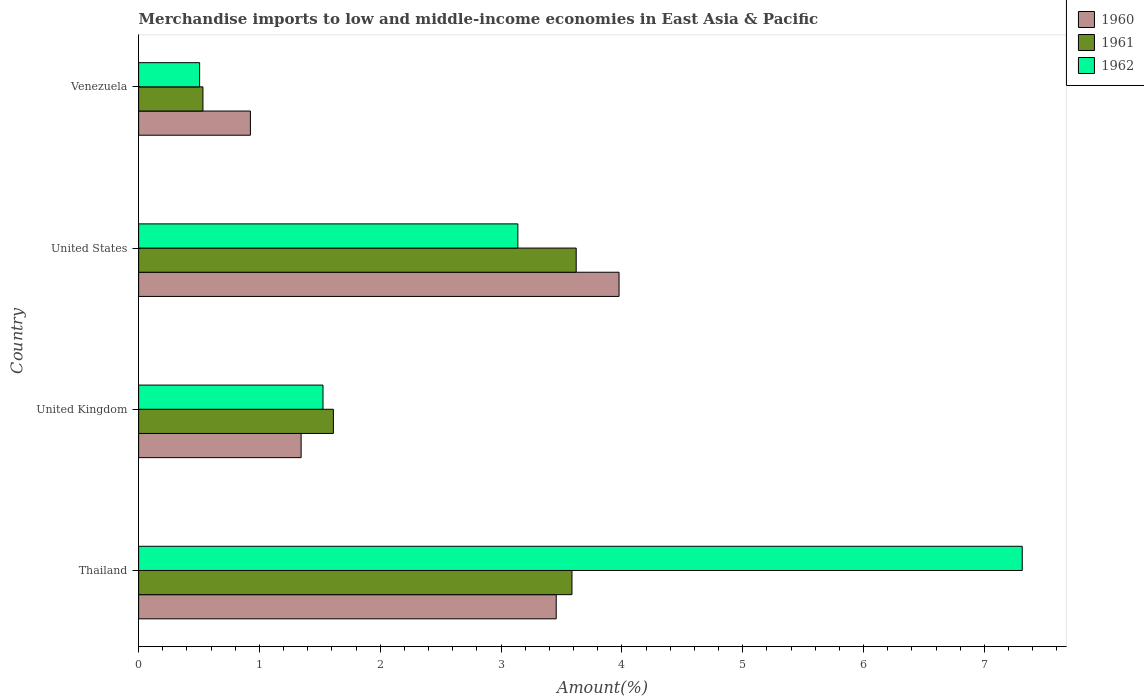How many groups of bars are there?
Your answer should be compact. 4. Are the number of bars per tick equal to the number of legend labels?
Provide a short and direct response. Yes. How many bars are there on the 4th tick from the top?
Make the answer very short. 3. What is the label of the 4th group of bars from the top?
Provide a succinct answer. Thailand. What is the percentage of amount earned from merchandise imports in 1960 in Thailand?
Offer a terse response. 3.46. Across all countries, what is the maximum percentage of amount earned from merchandise imports in 1960?
Provide a short and direct response. 3.98. Across all countries, what is the minimum percentage of amount earned from merchandise imports in 1961?
Provide a short and direct response. 0.53. In which country was the percentage of amount earned from merchandise imports in 1962 maximum?
Provide a succinct answer. Thailand. In which country was the percentage of amount earned from merchandise imports in 1962 minimum?
Give a very brief answer. Venezuela. What is the total percentage of amount earned from merchandise imports in 1960 in the graph?
Give a very brief answer. 9.7. What is the difference between the percentage of amount earned from merchandise imports in 1960 in Thailand and that in Venezuela?
Your response must be concise. 2.53. What is the difference between the percentage of amount earned from merchandise imports in 1961 in Venezuela and the percentage of amount earned from merchandise imports in 1962 in United States?
Provide a succinct answer. -2.61. What is the average percentage of amount earned from merchandise imports in 1962 per country?
Ensure brevity in your answer.  3.12. What is the difference between the percentage of amount earned from merchandise imports in 1961 and percentage of amount earned from merchandise imports in 1960 in Thailand?
Provide a short and direct response. 0.13. In how many countries, is the percentage of amount earned from merchandise imports in 1960 greater than 3.8 %?
Make the answer very short. 1. What is the ratio of the percentage of amount earned from merchandise imports in 1960 in Thailand to that in United States?
Your response must be concise. 0.87. Is the percentage of amount earned from merchandise imports in 1960 in Thailand less than that in Venezuela?
Provide a short and direct response. No. What is the difference between the highest and the second highest percentage of amount earned from merchandise imports in 1960?
Your answer should be very brief. 0.52. What is the difference between the highest and the lowest percentage of amount earned from merchandise imports in 1961?
Ensure brevity in your answer.  3.09. In how many countries, is the percentage of amount earned from merchandise imports in 1961 greater than the average percentage of amount earned from merchandise imports in 1961 taken over all countries?
Your answer should be very brief. 2. Is the sum of the percentage of amount earned from merchandise imports in 1960 in Thailand and United States greater than the maximum percentage of amount earned from merchandise imports in 1962 across all countries?
Offer a very short reply. Yes. Is it the case that in every country, the sum of the percentage of amount earned from merchandise imports in 1962 and percentage of amount earned from merchandise imports in 1960 is greater than the percentage of amount earned from merchandise imports in 1961?
Give a very brief answer. Yes. How many bars are there?
Keep it short and to the point. 12. Are all the bars in the graph horizontal?
Give a very brief answer. Yes. How many countries are there in the graph?
Your answer should be compact. 4. Are the values on the major ticks of X-axis written in scientific E-notation?
Provide a short and direct response. No. Does the graph contain any zero values?
Keep it short and to the point. No. How are the legend labels stacked?
Your answer should be very brief. Vertical. What is the title of the graph?
Your answer should be very brief. Merchandise imports to low and middle-income economies in East Asia & Pacific. What is the label or title of the X-axis?
Keep it short and to the point. Amount(%). What is the label or title of the Y-axis?
Your response must be concise. Country. What is the Amount(%) of 1960 in Thailand?
Provide a short and direct response. 3.46. What is the Amount(%) of 1961 in Thailand?
Provide a short and direct response. 3.59. What is the Amount(%) of 1962 in Thailand?
Your response must be concise. 7.31. What is the Amount(%) of 1960 in United Kingdom?
Offer a terse response. 1.34. What is the Amount(%) in 1961 in United Kingdom?
Your answer should be compact. 1.61. What is the Amount(%) in 1962 in United Kingdom?
Keep it short and to the point. 1.53. What is the Amount(%) in 1960 in United States?
Offer a very short reply. 3.98. What is the Amount(%) in 1961 in United States?
Offer a very short reply. 3.62. What is the Amount(%) of 1962 in United States?
Give a very brief answer. 3.14. What is the Amount(%) in 1960 in Venezuela?
Offer a very short reply. 0.93. What is the Amount(%) of 1961 in Venezuela?
Your response must be concise. 0.53. What is the Amount(%) in 1962 in Venezuela?
Provide a short and direct response. 0.5. Across all countries, what is the maximum Amount(%) of 1960?
Your answer should be compact. 3.98. Across all countries, what is the maximum Amount(%) of 1961?
Provide a succinct answer. 3.62. Across all countries, what is the maximum Amount(%) of 1962?
Your answer should be very brief. 7.31. Across all countries, what is the minimum Amount(%) in 1960?
Provide a succinct answer. 0.93. Across all countries, what is the minimum Amount(%) in 1961?
Provide a short and direct response. 0.53. Across all countries, what is the minimum Amount(%) of 1962?
Keep it short and to the point. 0.5. What is the total Amount(%) of 1960 in the graph?
Provide a short and direct response. 9.7. What is the total Amount(%) in 1961 in the graph?
Ensure brevity in your answer.  9.35. What is the total Amount(%) in 1962 in the graph?
Give a very brief answer. 12.48. What is the difference between the Amount(%) in 1960 in Thailand and that in United Kingdom?
Offer a very short reply. 2.11. What is the difference between the Amount(%) in 1961 in Thailand and that in United Kingdom?
Provide a succinct answer. 1.97. What is the difference between the Amount(%) of 1962 in Thailand and that in United Kingdom?
Keep it short and to the point. 5.79. What is the difference between the Amount(%) in 1960 in Thailand and that in United States?
Give a very brief answer. -0.52. What is the difference between the Amount(%) of 1961 in Thailand and that in United States?
Your answer should be compact. -0.04. What is the difference between the Amount(%) in 1962 in Thailand and that in United States?
Provide a succinct answer. 4.17. What is the difference between the Amount(%) in 1960 in Thailand and that in Venezuela?
Keep it short and to the point. 2.53. What is the difference between the Amount(%) of 1961 in Thailand and that in Venezuela?
Make the answer very short. 3.05. What is the difference between the Amount(%) of 1962 in Thailand and that in Venezuela?
Provide a succinct answer. 6.81. What is the difference between the Amount(%) in 1960 in United Kingdom and that in United States?
Ensure brevity in your answer.  -2.63. What is the difference between the Amount(%) in 1961 in United Kingdom and that in United States?
Give a very brief answer. -2.01. What is the difference between the Amount(%) in 1962 in United Kingdom and that in United States?
Provide a short and direct response. -1.61. What is the difference between the Amount(%) of 1960 in United Kingdom and that in Venezuela?
Your response must be concise. 0.42. What is the difference between the Amount(%) of 1961 in United Kingdom and that in Venezuela?
Your response must be concise. 1.08. What is the difference between the Amount(%) of 1962 in United Kingdom and that in Venezuela?
Offer a terse response. 1.02. What is the difference between the Amount(%) of 1960 in United States and that in Venezuela?
Offer a terse response. 3.05. What is the difference between the Amount(%) of 1961 in United States and that in Venezuela?
Provide a succinct answer. 3.09. What is the difference between the Amount(%) of 1962 in United States and that in Venezuela?
Your response must be concise. 2.63. What is the difference between the Amount(%) of 1960 in Thailand and the Amount(%) of 1961 in United Kingdom?
Your response must be concise. 1.84. What is the difference between the Amount(%) in 1960 in Thailand and the Amount(%) in 1962 in United Kingdom?
Provide a succinct answer. 1.93. What is the difference between the Amount(%) of 1961 in Thailand and the Amount(%) of 1962 in United Kingdom?
Offer a terse response. 2.06. What is the difference between the Amount(%) in 1960 in Thailand and the Amount(%) in 1961 in United States?
Keep it short and to the point. -0.17. What is the difference between the Amount(%) in 1960 in Thailand and the Amount(%) in 1962 in United States?
Your answer should be very brief. 0.32. What is the difference between the Amount(%) in 1961 in Thailand and the Amount(%) in 1962 in United States?
Make the answer very short. 0.45. What is the difference between the Amount(%) in 1960 in Thailand and the Amount(%) in 1961 in Venezuela?
Make the answer very short. 2.92. What is the difference between the Amount(%) of 1960 in Thailand and the Amount(%) of 1962 in Venezuela?
Your response must be concise. 2.95. What is the difference between the Amount(%) of 1961 in Thailand and the Amount(%) of 1962 in Venezuela?
Provide a succinct answer. 3.08. What is the difference between the Amount(%) of 1960 in United Kingdom and the Amount(%) of 1961 in United States?
Provide a succinct answer. -2.28. What is the difference between the Amount(%) in 1960 in United Kingdom and the Amount(%) in 1962 in United States?
Keep it short and to the point. -1.79. What is the difference between the Amount(%) in 1961 in United Kingdom and the Amount(%) in 1962 in United States?
Offer a very short reply. -1.53. What is the difference between the Amount(%) in 1960 in United Kingdom and the Amount(%) in 1961 in Venezuela?
Give a very brief answer. 0.81. What is the difference between the Amount(%) of 1960 in United Kingdom and the Amount(%) of 1962 in Venezuela?
Offer a terse response. 0.84. What is the difference between the Amount(%) of 1961 in United Kingdom and the Amount(%) of 1962 in Venezuela?
Ensure brevity in your answer.  1.11. What is the difference between the Amount(%) in 1960 in United States and the Amount(%) in 1961 in Venezuela?
Offer a terse response. 3.44. What is the difference between the Amount(%) in 1960 in United States and the Amount(%) in 1962 in Venezuela?
Offer a very short reply. 3.47. What is the difference between the Amount(%) of 1961 in United States and the Amount(%) of 1962 in Venezuela?
Your response must be concise. 3.12. What is the average Amount(%) in 1960 per country?
Provide a succinct answer. 2.43. What is the average Amount(%) of 1961 per country?
Provide a short and direct response. 2.34. What is the average Amount(%) in 1962 per country?
Offer a terse response. 3.12. What is the difference between the Amount(%) of 1960 and Amount(%) of 1961 in Thailand?
Offer a very short reply. -0.13. What is the difference between the Amount(%) in 1960 and Amount(%) in 1962 in Thailand?
Offer a terse response. -3.86. What is the difference between the Amount(%) in 1961 and Amount(%) in 1962 in Thailand?
Offer a very short reply. -3.73. What is the difference between the Amount(%) in 1960 and Amount(%) in 1961 in United Kingdom?
Keep it short and to the point. -0.27. What is the difference between the Amount(%) in 1960 and Amount(%) in 1962 in United Kingdom?
Provide a short and direct response. -0.18. What is the difference between the Amount(%) of 1961 and Amount(%) of 1962 in United Kingdom?
Make the answer very short. 0.09. What is the difference between the Amount(%) of 1960 and Amount(%) of 1961 in United States?
Your answer should be compact. 0.35. What is the difference between the Amount(%) of 1960 and Amount(%) of 1962 in United States?
Give a very brief answer. 0.84. What is the difference between the Amount(%) in 1961 and Amount(%) in 1962 in United States?
Offer a terse response. 0.48. What is the difference between the Amount(%) of 1960 and Amount(%) of 1961 in Venezuela?
Make the answer very short. 0.39. What is the difference between the Amount(%) of 1960 and Amount(%) of 1962 in Venezuela?
Offer a very short reply. 0.42. What is the difference between the Amount(%) in 1961 and Amount(%) in 1962 in Venezuela?
Your response must be concise. 0.03. What is the ratio of the Amount(%) in 1960 in Thailand to that in United Kingdom?
Provide a short and direct response. 2.57. What is the ratio of the Amount(%) of 1961 in Thailand to that in United Kingdom?
Keep it short and to the point. 2.23. What is the ratio of the Amount(%) of 1962 in Thailand to that in United Kingdom?
Make the answer very short. 4.79. What is the ratio of the Amount(%) in 1960 in Thailand to that in United States?
Offer a very short reply. 0.87. What is the ratio of the Amount(%) of 1961 in Thailand to that in United States?
Ensure brevity in your answer.  0.99. What is the ratio of the Amount(%) in 1962 in Thailand to that in United States?
Your response must be concise. 2.33. What is the ratio of the Amount(%) in 1960 in Thailand to that in Venezuela?
Make the answer very short. 3.74. What is the ratio of the Amount(%) of 1961 in Thailand to that in Venezuela?
Your response must be concise. 6.74. What is the ratio of the Amount(%) of 1962 in Thailand to that in Venezuela?
Your answer should be compact. 14.49. What is the ratio of the Amount(%) in 1960 in United Kingdom to that in United States?
Provide a short and direct response. 0.34. What is the ratio of the Amount(%) in 1961 in United Kingdom to that in United States?
Give a very brief answer. 0.45. What is the ratio of the Amount(%) of 1962 in United Kingdom to that in United States?
Ensure brevity in your answer.  0.49. What is the ratio of the Amount(%) of 1960 in United Kingdom to that in Venezuela?
Your answer should be compact. 1.45. What is the ratio of the Amount(%) of 1961 in United Kingdom to that in Venezuela?
Keep it short and to the point. 3.03. What is the ratio of the Amount(%) of 1962 in United Kingdom to that in Venezuela?
Keep it short and to the point. 3.02. What is the ratio of the Amount(%) of 1960 in United States to that in Venezuela?
Make the answer very short. 4.3. What is the ratio of the Amount(%) of 1961 in United States to that in Venezuela?
Ensure brevity in your answer.  6.8. What is the ratio of the Amount(%) of 1962 in United States to that in Venezuela?
Make the answer very short. 6.22. What is the difference between the highest and the second highest Amount(%) of 1960?
Keep it short and to the point. 0.52. What is the difference between the highest and the second highest Amount(%) of 1961?
Provide a succinct answer. 0.04. What is the difference between the highest and the second highest Amount(%) of 1962?
Offer a terse response. 4.17. What is the difference between the highest and the lowest Amount(%) in 1960?
Provide a succinct answer. 3.05. What is the difference between the highest and the lowest Amount(%) in 1961?
Provide a succinct answer. 3.09. What is the difference between the highest and the lowest Amount(%) in 1962?
Ensure brevity in your answer.  6.81. 